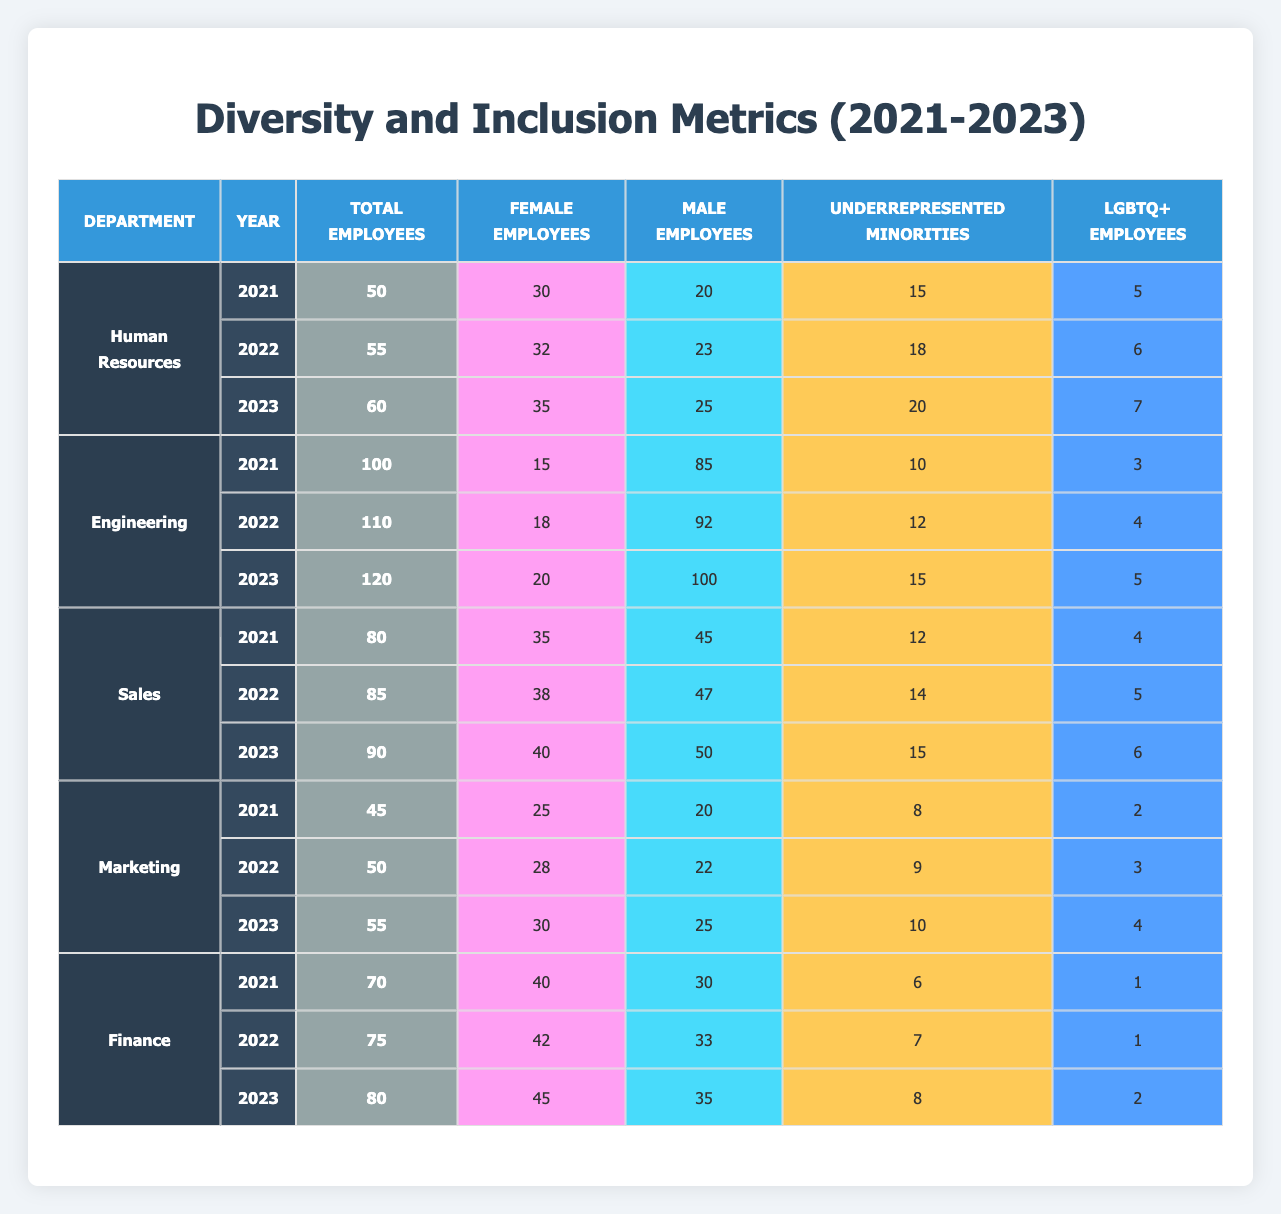What was the total number of employees in the Human Resources department in 2023? Referring to the table under the Human Resources section for the year 2023, the total number of employees is 60.
Answer: 60 How many female employees were in the Engineering department in 2022? In the Engineering department for the year 2022, there were 18 female employees listed in the table.
Answer: 18 Which department had the highest number of LGBTQ+ employees in 2023? In the table for 2023, each department's LGBTQ+ employee count shows that Human Resources had 7, Engineering had 5, Sales had 6, Marketing had 4, and Finance had 2. Therefore, Human Resources had the highest with 7.
Answer: Human Resources What is the average number of female employees across all departments in 2021? First, sum the female employees for all departments in 2021: (30 + 15 + 35 + 25 + 40) = 145. The number of departments is 5. So, the average is 145 / 5 = 29.
Answer: 29 Did the number of underrepresented minorities in Sales increase from 2021 to 2023? Referring to the table, in Sales, the number of underrepresented minorities in 2021 was 12 and in 2023 it was 15. This means there was an increase.
Answer: Yes Which department experienced the largest percentage increase in total employees from 2021 to 2023? To find the largest percentage increase, calculate the total employees for each department for both years: Human Resources (20%), Engineering (20%), Sales (12.5%), Marketing (22.22%), and Finance (14.29%). The highest percentage increase is in Marketing, calculated as ((55-45)/45)*100 = 22.22%.
Answer: Marketing How many male employees were there in Finance in 2023? Looking at the Finance department for 2023 in the table, there were 35 male employees.
Answer: 35 What is the total number of underrepresented minorities across all departments for the year 2022? Summing the underrepresented minorities from each department for 2022 gives: (18 + 12 + 14 + 9 + 7) = 60. Therefore, the total is 60.
Answer: 60 Which department had the least number of total employees in 2021? In 2021, the total employees by department were: 50 (HR), 100 (Engineering), 80 (Sales), 45 (Marketing), and 70 (Finance). The least was in Marketing with 45 employees.
Answer: Marketing What was the change in the number of female employees in the Engineering department between 2021 and 2023? In Engineering, the number of female employees was 15 in 2021 and increased to 20 by 2023, which is a change of 5 employees.
Answer: 5 Overall, did the percentage of female employees in Sales increase, decrease, or remain the same from 2021 to 2023? In Sales, the female employees were 35 in 2021 and 40 in 2023. The percentage of female employees increased from (35/80)*100 = 43.75% in 2021 to (40/90)*100 = 44.44% in 2023. Thus, it increased.
Answer: Increased 